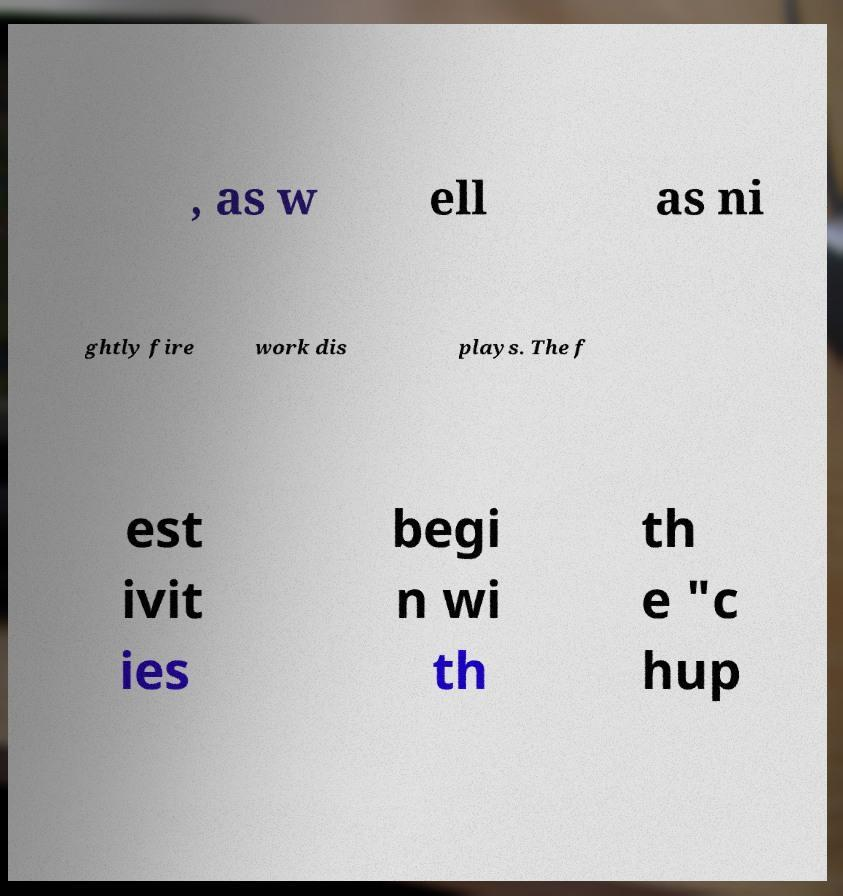Can you read and provide the text displayed in the image?This photo seems to have some interesting text. Can you extract and type it out for me? , as w ell as ni ghtly fire work dis plays. The f est ivit ies begi n wi th th e "c hup 